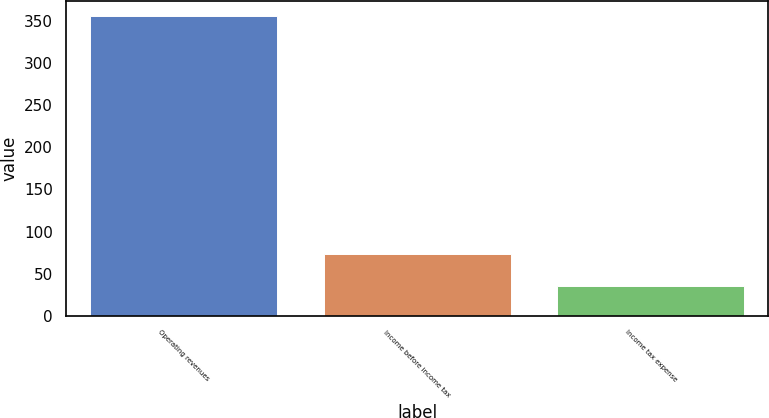Convert chart. <chart><loc_0><loc_0><loc_500><loc_500><bar_chart><fcel>Operating revenues<fcel>Income before income tax<fcel>Income tax expense<nl><fcel>356<fcel>73<fcel>35<nl></chart> 